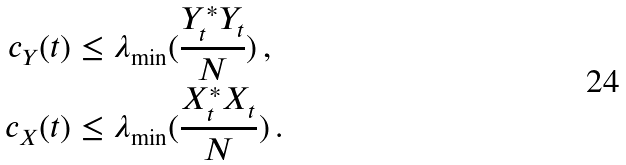<formula> <loc_0><loc_0><loc_500><loc_500>c _ { Y } ( t ) & \leq \lambda _ { \min } ( \frac { Y _ { t } ^ { * } Y _ { t } } { N } ) \, , \\ c _ { X } ( t ) & \leq \lambda _ { \min } ( \frac { X _ { t } ^ { * } X _ { t } } { N } ) \, .</formula> 